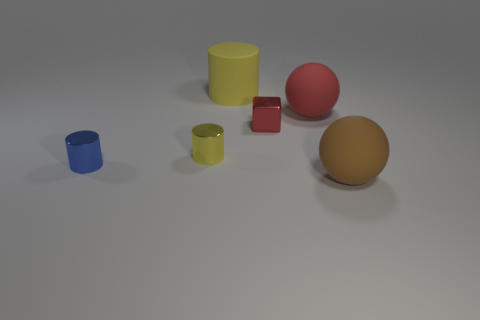Add 2 tiny red things. How many objects exist? 8 Subtract all cubes. How many objects are left? 5 Subtract all large balls. Subtract all yellow things. How many objects are left? 2 Add 5 tiny yellow cylinders. How many tiny yellow cylinders are left? 6 Add 5 red matte blocks. How many red matte blocks exist? 5 Subtract 0 gray blocks. How many objects are left? 6 